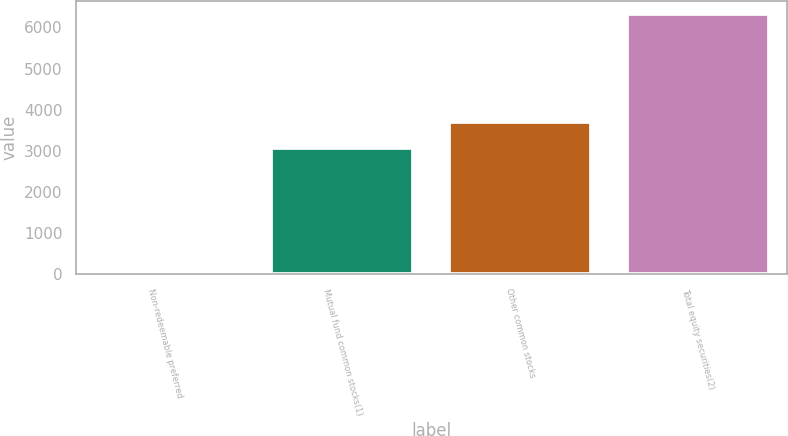Convert chart. <chart><loc_0><loc_0><loc_500><loc_500><bar_chart><fcel>Non-redeemable preferred<fcel>Mutual fund common stocks(1)<fcel>Other common stocks<fcel>Total equity securities(2)<nl><fcel>25<fcel>3076<fcel>3706.6<fcel>6331<nl></chart> 